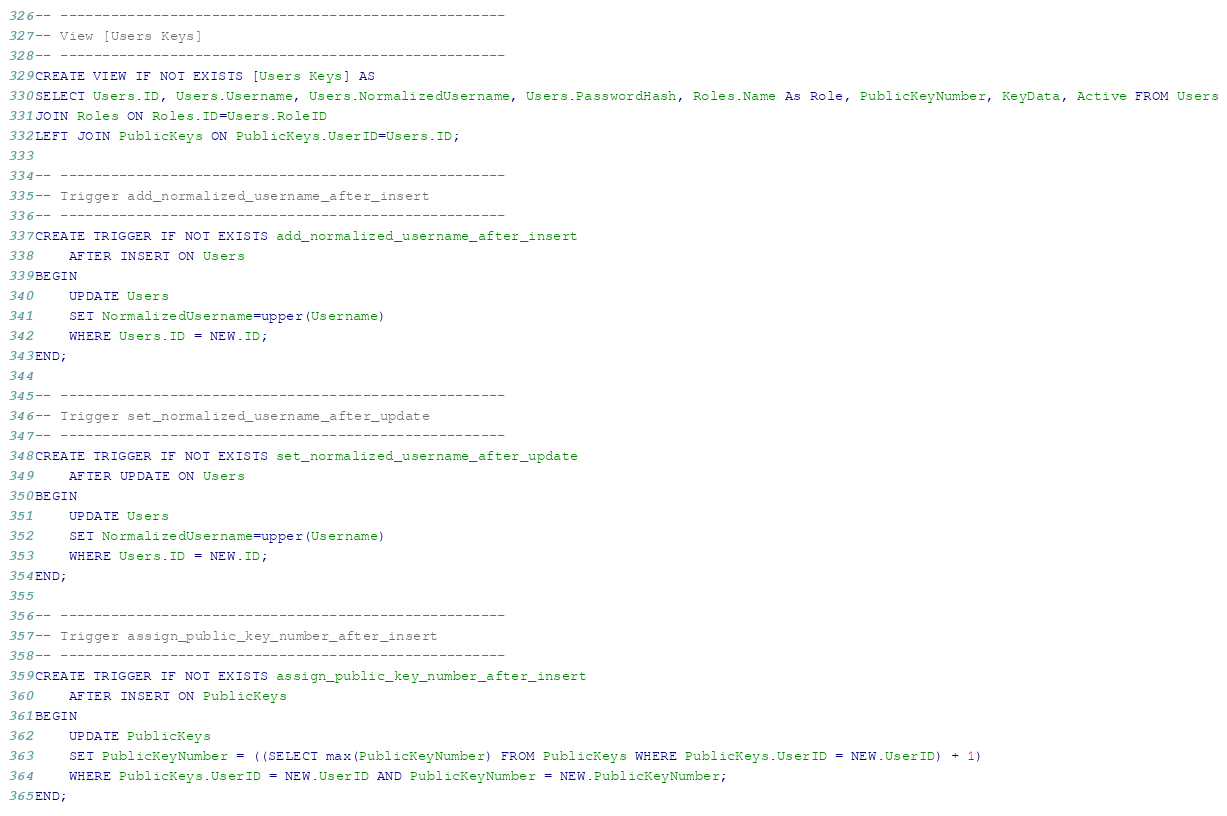Convert code to text. <code><loc_0><loc_0><loc_500><loc_500><_SQL_>
-- -----------------------------------------------------
-- View [Users Keys]
-- -----------------------------------------------------
CREATE VIEW IF NOT EXISTS [Users Keys] AS
SELECT Users.ID, Users.Username, Users.NormalizedUsername, Users.PasswordHash, Roles.Name As Role, PublicKeyNumber, KeyData, Active FROM Users
JOIN Roles ON Roles.ID=Users.RoleID
LEFT JOIN PublicKeys ON PublicKeys.UserID=Users.ID;

-- -----------------------------------------------------
-- Trigger add_normalized_username_after_insert
-- -----------------------------------------------------
CREATE TRIGGER IF NOT EXISTS add_normalized_username_after_insert
	AFTER INSERT ON Users
BEGIN
	UPDATE Users
	SET NormalizedUsername=upper(Username)
	WHERE Users.ID = NEW.ID;
END;

-- -----------------------------------------------------
-- Trigger set_normalized_username_after_update
-- -----------------------------------------------------
CREATE TRIGGER IF NOT EXISTS set_normalized_username_after_update
	AFTER UPDATE ON Users
BEGIN
	UPDATE Users
	SET NormalizedUsername=upper(Username)
	WHERE Users.ID = NEW.ID;
END;

-- -----------------------------------------------------
-- Trigger assign_public_key_number_after_insert
-- -----------------------------------------------------
CREATE TRIGGER IF NOT EXISTS assign_public_key_number_after_insert
	AFTER INSERT ON PublicKeys
BEGIN
	UPDATE PublicKeys
	SET PublicKeyNumber = ((SELECT max(PublicKeyNumber) FROM PublicKeys WHERE PublicKeys.UserID = NEW.UserID) + 1)
	WHERE PublicKeys.UserID = NEW.UserID AND PublicKeyNumber = NEW.PublicKeyNumber;
END;</code> 